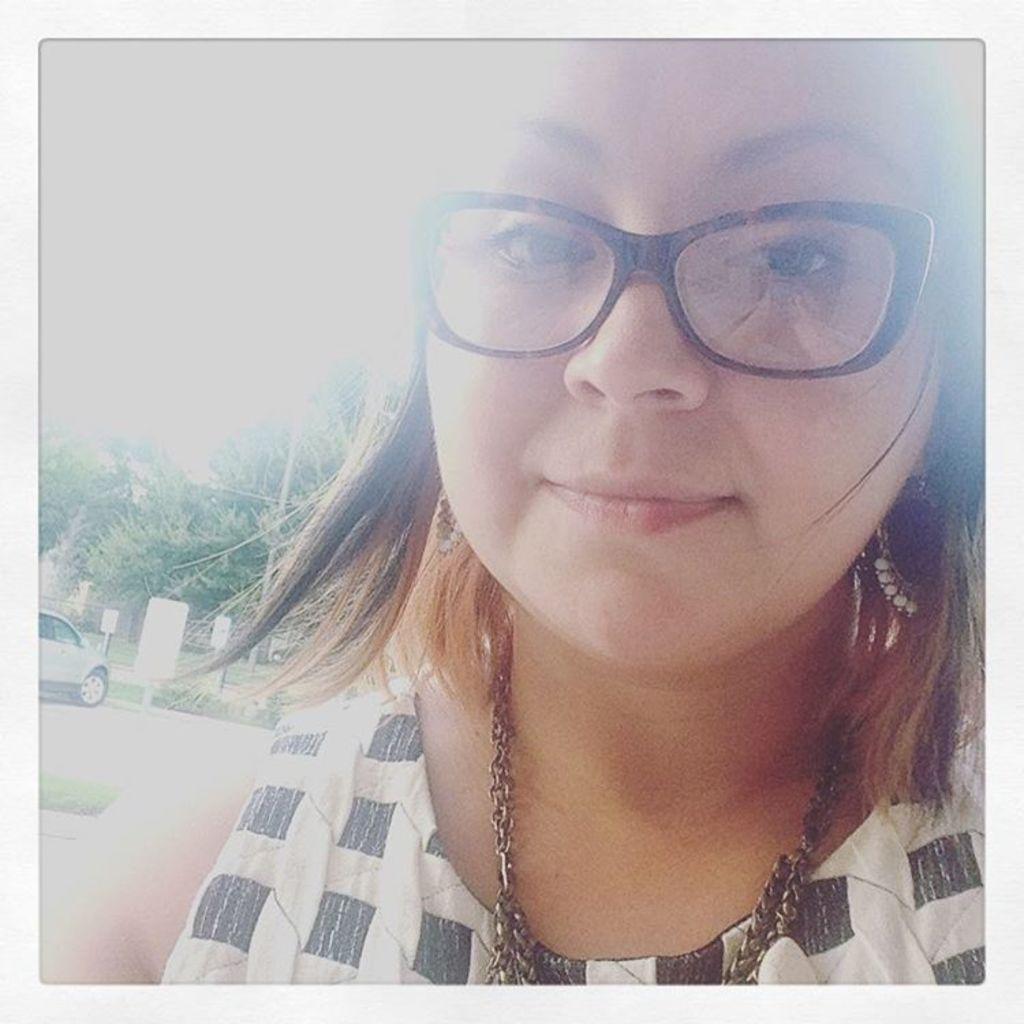How would you summarize this image in a sentence or two? In this image I can see a woman in the front. She is wearing spectacles. There is a car, boards and trees at the back. 